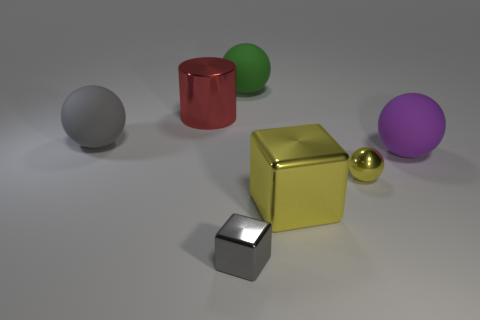What number of things are either large matte balls or big red things behind the purple object?
Offer a terse response. 4. There is a small shiny thing behind the big metal thing to the right of the large red metallic object; what color is it?
Your answer should be very brief. Yellow. How many other things are there of the same material as the small gray cube?
Make the answer very short. 3. What number of metallic objects are either yellow cubes or big green balls?
Provide a succinct answer. 1. The metallic thing that is the same shape as the big purple matte object is what color?
Provide a succinct answer. Yellow. How many things are either big balls or big objects?
Make the answer very short. 5. There is another large object that is made of the same material as the big yellow object; what shape is it?
Ensure brevity in your answer.  Cylinder. What number of tiny objects are either gray metal blocks or yellow metallic objects?
Your answer should be very brief. 2. How many other objects are the same color as the metallic sphere?
Give a very brief answer. 1. There is a cube on the left side of the ball that is behind the gray sphere; what number of tiny things are on the right side of it?
Make the answer very short. 1. 